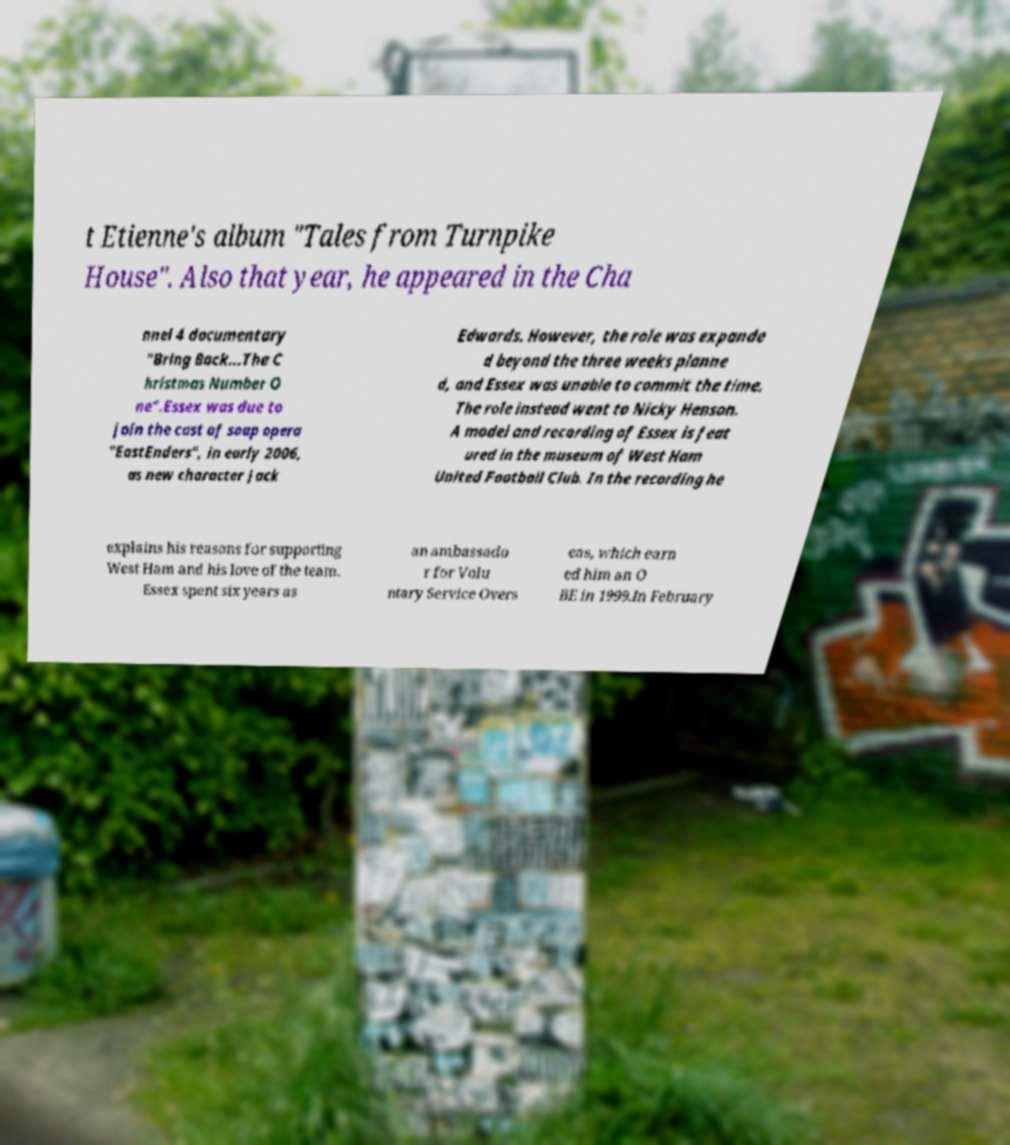Can you read and provide the text displayed in the image?This photo seems to have some interesting text. Can you extract and type it out for me? t Etienne's album "Tales from Turnpike House". Also that year, he appeared in the Cha nnel 4 documentary "Bring Back...The C hristmas Number O ne".Essex was due to join the cast of soap opera "EastEnders", in early 2006, as new character Jack Edwards. However, the role was expande d beyond the three weeks planne d, and Essex was unable to commit the time. The role instead went to Nicky Henson. A model and recording of Essex is feat ured in the museum of West Ham United Football Club. In the recording he explains his reasons for supporting West Ham and his love of the team. Essex spent six years as an ambassado r for Volu ntary Service Overs eas, which earn ed him an O BE in 1999.In February 